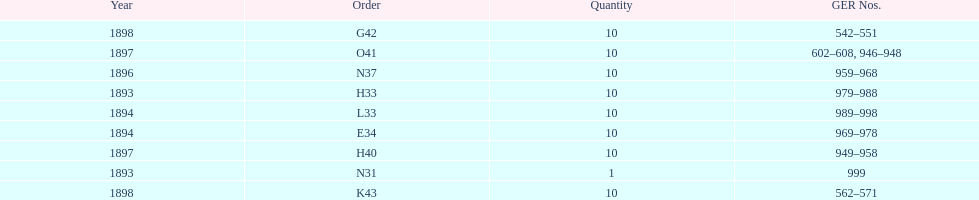What amount of time to the years span? 5 years. Would you mind parsing the complete table? {'header': ['Year', 'Order', 'Quantity', 'GER Nos.'], 'rows': [['1898', 'G42', '10', '542–551'], ['1897', 'O41', '10', '602–608, 946–948'], ['1896', 'N37', '10', '959–968'], ['1893', 'H33', '10', '979–988'], ['1894', 'L33', '10', '989–998'], ['1894', 'E34', '10', '969–978'], ['1897', 'H40', '10', '949–958'], ['1893', 'N31', '1', '999'], ['1898', 'K43', '10', '562–571']]} 